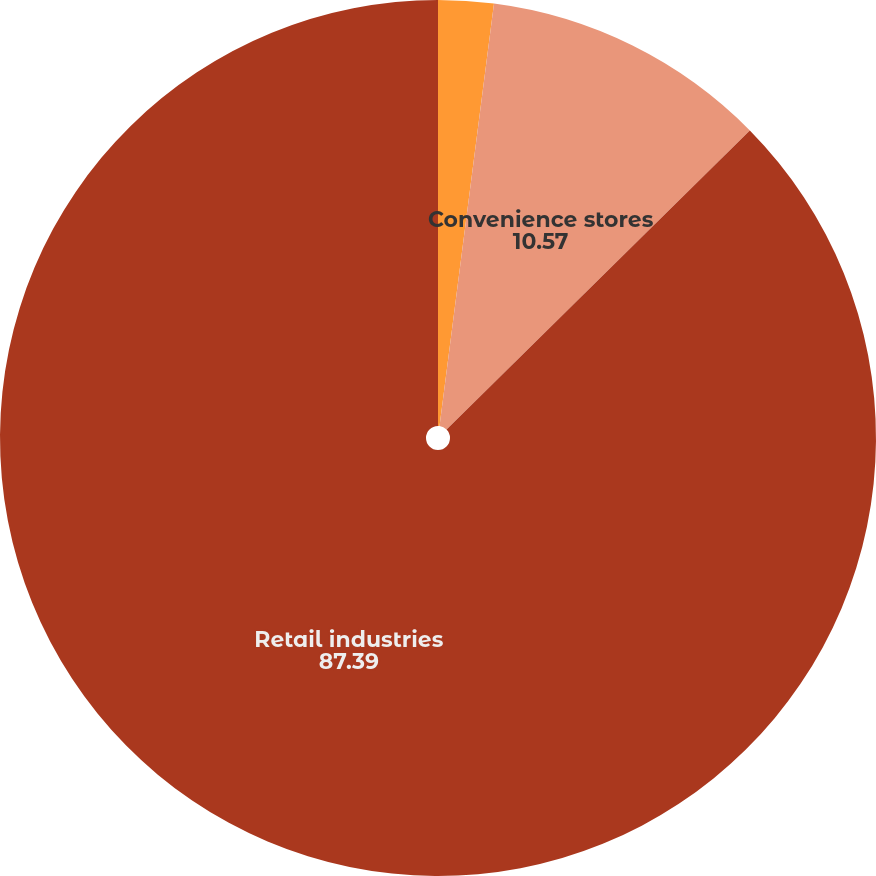Convert chart. <chart><loc_0><loc_0><loc_500><loc_500><pie_chart><fcel>Apparel stores<fcel>Convenience stores<fcel>Retail industries<nl><fcel>2.04%<fcel>10.57%<fcel>87.39%<nl></chart> 